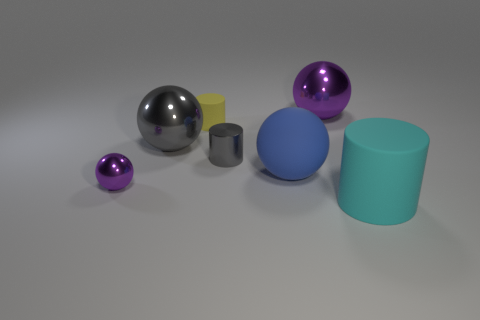Subtract 1 balls. How many balls are left? 3 Subtract all blue balls. How many balls are left? 3 Subtract all red balls. Subtract all cyan blocks. How many balls are left? 4 Add 3 purple metal things. How many objects exist? 10 Subtract all tiny objects. Subtract all small things. How many objects are left? 1 Add 1 yellow cylinders. How many yellow cylinders are left? 2 Add 7 big purple spheres. How many big purple spheres exist? 8 Subtract 0 yellow balls. How many objects are left? 7 Subtract all cylinders. How many objects are left? 4 